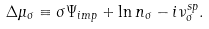<formula> <loc_0><loc_0><loc_500><loc_500>\Delta \mu _ { \sigma } \equiv \sigma \Psi _ { i m p } + \ln n _ { \sigma } - i \nu _ { \sigma } ^ { s p } .</formula> 